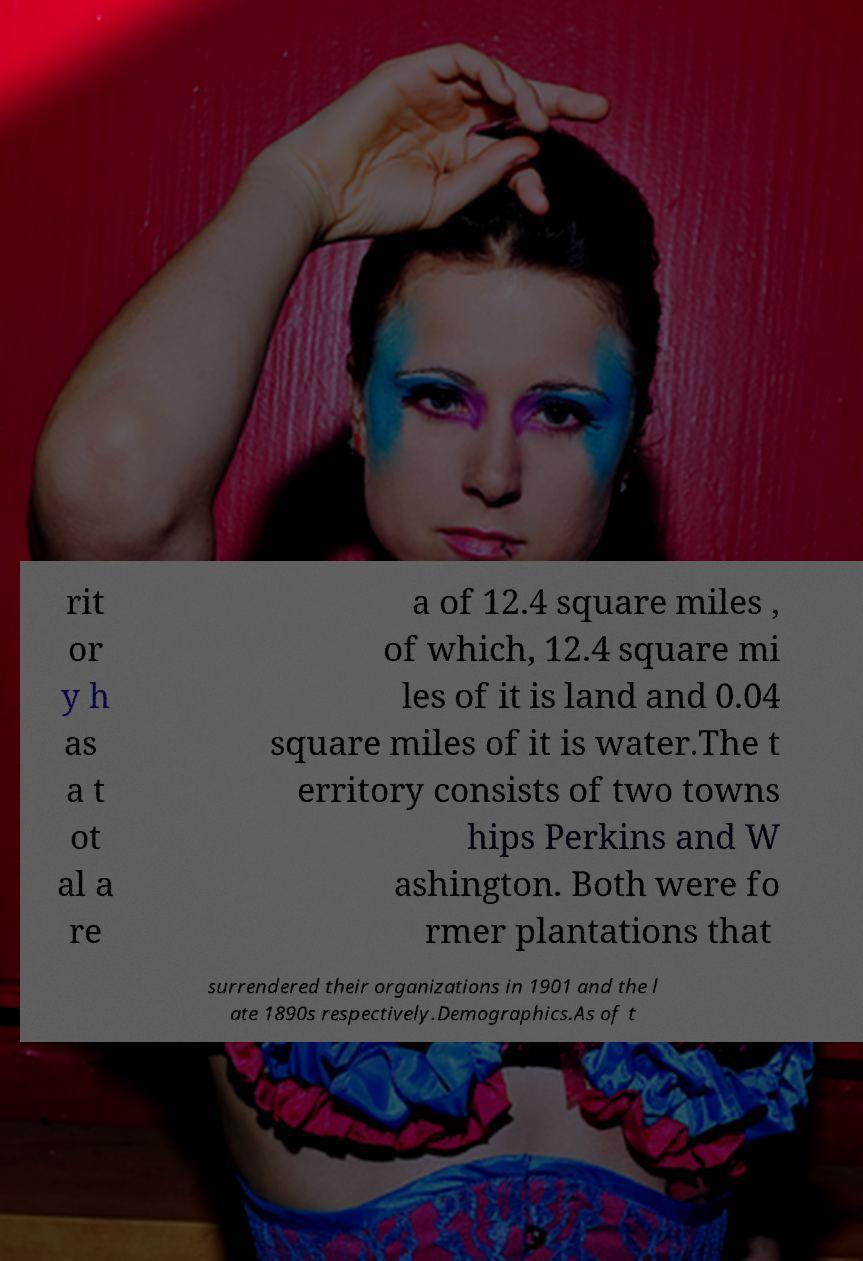For documentation purposes, I need the text within this image transcribed. Could you provide that? rit or y h as a t ot al a re a of 12.4 square miles , of which, 12.4 square mi les of it is land and 0.04 square miles of it is water.The t erritory consists of two towns hips Perkins and W ashington. Both were fo rmer plantations that surrendered their organizations in 1901 and the l ate 1890s respectively.Demographics.As of t 